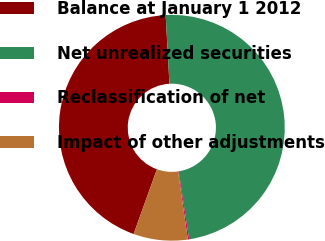<chart> <loc_0><loc_0><loc_500><loc_500><pie_chart><fcel>Balance at January 1 2012<fcel>Net unrealized securities<fcel>Reclassification of net<fcel>Impact of other adjustments<nl><fcel>43.64%<fcel>48.42%<fcel>0.19%<fcel>7.76%<nl></chart> 